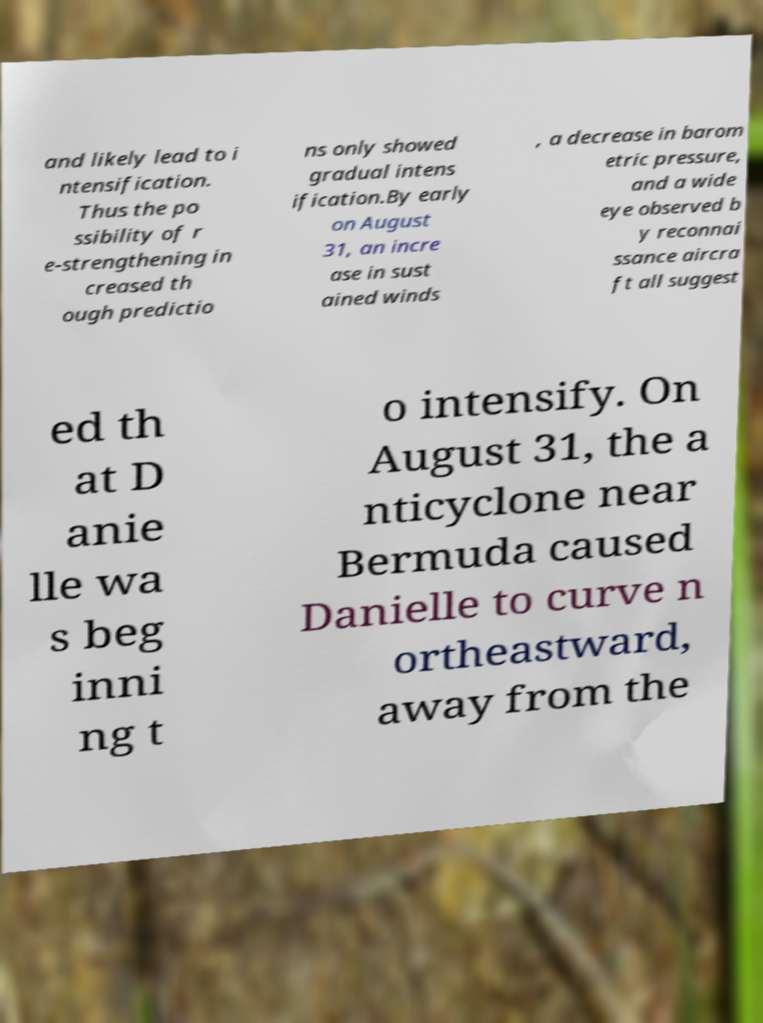Can you accurately transcribe the text from the provided image for me? and likely lead to i ntensification. Thus the po ssibility of r e-strengthening in creased th ough predictio ns only showed gradual intens ification.By early on August 31, an incre ase in sust ained winds , a decrease in barom etric pressure, and a wide eye observed b y reconnai ssance aircra ft all suggest ed th at D anie lle wa s beg inni ng t o intensify. On August 31, the a nticyclone near Bermuda caused Danielle to curve n ortheastward, away from the 